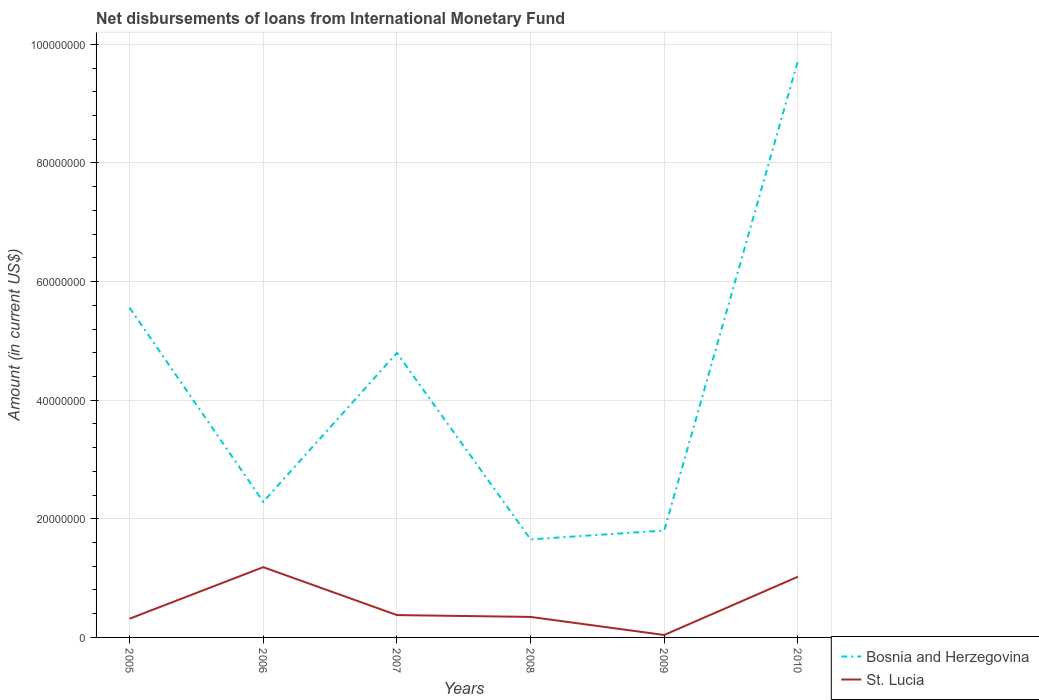How many different coloured lines are there?
Give a very brief answer. 2. Does the line corresponding to Bosnia and Herzegovina intersect with the line corresponding to St. Lucia?
Give a very brief answer. No. Is the number of lines equal to the number of legend labels?
Keep it short and to the point. Yes. Across all years, what is the maximum amount of loans disbursed in St. Lucia?
Provide a succinct answer. 4.12e+05. In which year was the amount of loans disbursed in St. Lucia maximum?
Provide a short and direct response. 2009. What is the total amount of loans disbursed in St. Lucia in the graph?
Ensure brevity in your answer.  3.04e+06. What is the difference between the highest and the second highest amount of loans disbursed in St. Lucia?
Provide a succinct answer. 1.14e+07. How many years are there in the graph?
Provide a succinct answer. 6. Are the values on the major ticks of Y-axis written in scientific E-notation?
Offer a very short reply. No. Does the graph contain grids?
Keep it short and to the point. Yes. Where does the legend appear in the graph?
Ensure brevity in your answer.  Bottom right. How many legend labels are there?
Your answer should be very brief. 2. What is the title of the graph?
Your response must be concise. Net disbursements of loans from International Monetary Fund. What is the label or title of the Y-axis?
Ensure brevity in your answer.  Amount (in current US$). What is the Amount (in current US$) of Bosnia and Herzegovina in 2005?
Your response must be concise. 5.56e+07. What is the Amount (in current US$) of St. Lucia in 2005?
Offer a very short reply. 3.16e+06. What is the Amount (in current US$) in Bosnia and Herzegovina in 2006?
Offer a very short reply. 2.29e+07. What is the Amount (in current US$) in St. Lucia in 2006?
Your answer should be very brief. 1.18e+07. What is the Amount (in current US$) in Bosnia and Herzegovina in 2007?
Your response must be concise. 4.80e+07. What is the Amount (in current US$) in St. Lucia in 2007?
Make the answer very short. 3.77e+06. What is the Amount (in current US$) of Bosnia and Herzegovina in 2008?
Give a very brief answer. 1.65e+07. What is the Amount (in current US$) in St. Lucia in 2008?
Provide a short and direct response. 3.46e+06. What is the Amount (in current US$) in Bosnia and Herzegovina in 2009?
Your answer should be very brief. 1.80e+07. What is the Amount (in current US$) of St. Lucia in 2009?
Make the answer very short. 4.12e+05. What is the Amount (in current US$) of Bosnia and Herzegovina in 2010?
Ensure brevity in your answer.  9.72e+07. What is the Amount (in current US$) in St. Lucia in 2010?
Provide a short and direct response. 1.02e+07. Across all years, what is the maximum Amount (in current US$) of Bosnia and Herzegovina?
Make the answer very short. 9.72e+07. Across all years, what is the maximum Amount (in current US$) of St. Lucia?
Your answer should be very brief. 1.18e+07. Across all years, what is the minimum Amount (in current US$) in Bosnia and Herzegovina?
Provide a succinct answer. 1.65e+07. Across all years, what is the minimum Amount (in current US$) in St. Lucia?
Your answer should be very brief. 4.12e+05. What is the total Amount (in current US$) in Bosnia and Herzegovina in the graph?
Your answer should be very brief. 2.58e+08. What is the total Amount (in current US$) of St. Lucia in the graph?
Your response must be concise. 3.29e+07. What is the difference between the Amount (in current US$) in Bosnia and Herzegovina in 2005 and that in 2006?
Offer a terse response. 3.27e+07. What is the difference between the Amount (in current US$) in St. Lucia in 2005 and that in 2006?
Keep it short and to the point. -8.69e+06. What is the difference between the Amount (in current US$) in Bosnia and Herzegovina in 2005 and that in 2007?
Provide a short and direct response. 7.63e+06. What is the difference between the Amount (in current US$) in St. Lucia in 2005 and that in 2007?
Your answer should be very brief. -6.09e+05. What is the difference between the Amount (in current US$) of Bosnia and Herzegovina in 2005 and that in 2008?
Provide a succinct answer. 3.91e+07. What is the difference between the Amount (in current US$) of St. Lucia in 2005 and that in 2008?
Provide a succinct answer. -2.97e+05. What is the difference between the Amount (in current US$) in Bosnia and Herzegovina in 2005 and that in 2009?
Your answer should be very brief. 3.76e+07. What is the difference between the Amount (in current US$) in St. Lucia in 2005 and that in 2009?
Offer a terse response. 2.75e+06. What is the difference between the Amount (in current US$) of Bosnia and Herzegovina in 2005 and that in 2010?
Provide a short and direct response. -4.16e+07. What is the difference between the Amount (in current US$) in St. Lucia in 2005 and that in 2010?
Keep it short and to the point. -7.07e+06. What is the difference between the Amount (in current US$) in Bosnia and Herzegovina in 2006 and that in 2007?
Give a very brief answer. -2.51e+07. What is the difference between the Amount (in current US$) in St. Lucia in 2006 and that in 2007?
Provide a succinct answer. 8.08e+06. What is the difference between the Amount (in current US$) of Bosnia and Herzegovina in 2006 and that in 2008?
Provide a succinct answer. 6.33e+06. What is the difference between the Amount (in current US$) in St. Lucia in 2006 and that in 2008?
Your answer should be very brief. 8.39e+06. What is the difference between the Amount (in current US$) of Bosnia and Herzegovina in 2006 and that in 2009?
Your response must be concise. 4.84e+06. What is the difference between the Amount (in current US$) of St. Lucia in 2006 and that in 2009?
Keep it short and to the point. 1.14e+07. What is the difference between the Amount (in current US$) of Bosnia and Herzegovina in 2006 and that in 2010?
Provide a succinct answer. -7.43e+07. What is the difference between the Amount (in current US$) in St. Lucia in 2006 and that in 2010?
Provide a succinct answer. 1.62e+06. What is the difference between the Amount (in current US$) of Bosnia and Herzegovina in 2007 and that in 2008?
Ensure brevity in your answer.  3.14e+07. What is the difference between the Amount (in current US$) in St. Lucia in 2007 and that in 2008?
Provide a short and direct response. 3.12e+05. What is the difference between the Amount (in current US$) in Bosnia and Herzegovina in 2007 and that in 2009?
Ensure brevity in your answer.  2.99e+07. What is the difference between the Amount (in current US$) of St. Lucia in 2007 and that in 2009?
Give a very brief answer. 3.36e+06. What is the difference between the Amount (in current US$) in Bosnia and Herzegovina in 2007 and that in 2010?
Make the answer very short. -4.92e+07. What is the difference between the Amount (in current US$) in St. Lucia in 2007 and that in 2010?
Your answer should be very brief. -6.46e+06. What is the difference between the Amount (in current US$) in Bosnia and Herzegovina in 2008 and that in 2009?
Your answer should be very brief. -1.49e+06. What is the difference between the Amount (in current US$) of St. Lucia in 2008 and that in 2009?
Make the answer very short. 3.04e+06. What is the difference between the Amount (in current US$) in Bosnia and Herzegovina in 2008 and that in 2010?
Offer a terse response. -8.07e+07. What is the difference between the Amount (in current US$) in St. Lucia in 2008 and that in 2010?
Your answer should be compact. -6.77e+06. What is the difference between the Amount (in current US$) in Bosnia and Herzegovina in 2009 and that in 2010?
Offer a terse response. -7.92e+07. What is the difference between the Amount (in current US$) in St. Lucia in 2009 and that in 2010?
Ensure brevity in your answer.  -9.82e+06. What is the difference between the Amount (in current US$) of Bosnia and Herzegovina in 2005 and the Amount (in current US$) of St. Lucia in 2006?
Provide a short and direct response. 4.37e+07. What is the difference between the Amount (in current US$) in Bosnia and Herzegovina in 2005 and the Amount (in current US$) in St. Lucia in 2007?
Keep it short and to the point. 5.18e+07. What is the difference between the Amount (in current US$) of Bosnia and Herzegovina in 2005 and the Amount (in current US$) of St. Lucia in 2008?
Your answer should be compact. 5.21e+07. What is the difference between the Amount (in current US$) of Bosnia and Herzegovina in 2005 and the Amount (in current US$) of St. Lucia in 2009?
Offer a very short reply. 5.52e+07. What is the difference between the Amount (in current US$) in Bosnia and Herzegovina in 2005 and the Amount (in current US$) in St. Lucia in 2010?
Offer a terse response. 4.54e+07. What is the difference between the Amount (in current US$) of Bosnia and Herzegovina in 2006 and the Amount (in current US$) of St. Lucia in 2007?
Make the answer very short. 1.91e+07. What is the difference between the Amount (in current US$) in Bosnia and Herzegovina in 2006 and the Amount (in current US$) in St. Lucia in 2008?
Provide a succinct answer. 1.94e+07. What is the difference between the Amount (in current US$) in Bosnia and Herzegovina in 2006 and the Amount (in current US$) in St. Lucia in 2009?
Your answer should be compact. 2.25e+07. What is the difference between the Amount (in current US$) of Bosnia and Herzegovina in 2006 and the Amount (in current US$) of St. Lucia in 2010?
Make the answer very short. 1.26e+07. What is the difference between the Amount (in current US$) of Bosnia and Herzegovina in 2007 and the Amount (in current US$) of St. Lucia in 2008?
Your answer should be very brief. 4.45e+07. What is the difference between the Amount (in current US$) in Bosnia and Herzegovina in 2007 and the Amount (in current US$) in St. Lucia in 2009?
Offer a very short reply. 4.76e+07. What is the difference between the Amount (in current US$) in Bosnia and Herzegovina in 2007 and the Amount (in current US$) in St. Lucia in 2010?
Your response must be concise. 3.77e+07. What is the difference between the Amount (in current US$) of Bosnia and Herzegovina in 2008 and the Amount (in current US$) of St. Lucia in 2009?
Your answer should be compact. 1.61e+07. What is the difference between the Amount (in current US$) in Bosnia and Herzegovina in 2008 and the Amount (in current US$) in St. Lucia in 2010?
Make the answer very short. 6.30e+06. What is the difference between the Amount (in current US$) of Bosnia and Herzegovina in 2009 and the Amount (in current US$) of St. Lucia in 2010?
Provide a short and direct response. 7.79e+06. What is the average Amount (in current US$) of Bosnia and Herzegovina per year?
Keep it short and to the point. 4.30e+07. What is the average Amount (in current US$) of St. Lucia per year?
Offer a terse response. 5.48e+06. In the year 2005, what is the difference between the Amount (in current US$) in Bosnia and Herzegovina and Amount (in current US$) in St. Lucia?
Your answer should be compact. 5.24e+07. In the year 2006, what is the difference between the Amount (in current US$) of Bosnia and Herzegovina and Amount (in current US$) of St. Lucia?
Offer a very short reply. 1.10e+07. In the year 2007, what is the difference between the Amount (in current US$) in Bosnia and Herzegovina and Amount (in current US$) in St. Lucia?
Provide a short and direct response. 4.42e+07. In the year 2008, what is the difference between the Amount (in current US$) in Bosnia and Herzegovina and Amount (in current US$) in St. Lucia?
Provide a short and direct response. 1.31e+07. In the year 2009, what is the difference between the Amount (in current US$) in Bosnia and Herzegovina and Amount (in current US$) in St. Lucia?
Your answer should be very brief. 1.76e+07. In the year 2010, what is the difference between the Amount (in current US$) in Bosnia and Herzegovina and Amount (in current US$) in St. Lucia?
Give a very brief answer. 8.70e+07. What is the ratio of the Amount (in current US$) of Bosnia and Herzegovina in 2005 to that in 2006?
Ensure brevity in your answer.  2.43. What is the ratio of the Amount (in current US$) in St. Lucia in 2005 to that in 2006?
Ensure brevity in your answer.  0.27. What is the ratio of the Amount (in current US$) of Bosnia and Herzegovina in 2005 to that in 2007?
Provide a succinct answer. 1.16. What is the ratio of the Amount (in current US$) of St. Lucia in 2005 to that in 2007?
Offer a very short reply. 0.84. What is the ratio of the Amount (in current US$) in Bosnia and Herzegovina in 2005 to that in 2008?
Your answer should be compact. 3.36. What is the ratio of the Amount (in current US$) of St. Lucia in 2005 to that in 2008?
Make the answer very short. 0.91. What is the ratio of the Amount (in current US$) in Bosnia and Herzegovina in 2005 to that in 2009?
Your response must be concise. 3.08. What is the ratio of the Amount (in current US$) of St. Lucia in 2005 to that in 2009?
Keep it short and to the point. 7.67. What is the ratio of the Amount (in current US$) in Bosnia and Herzegovina in 2005 to that in 2010?
Keep it short and to the point. 0.57. What is the ratio of the Amount (in current US$) of St. Lucia in 2005 to that in 2010?
Your answer should be very brief. 0.31. What is the ratio of the Amount (in current US$) in Bosnia and Herzegovina in 2006 to that in 2007?
Your answer should be very brief. 0.48. What is the ratio of the Amount (in current US$) of St. Lucia in 2006 to that in 2007?
Keep it short and to the point. 3.14. What is the ratio of the Amount (in current US$) in Bosnia and Herzegovina in 2006 to that in 2008?
Your response must be concise. 1.38. What is the ratio of the Amount (in current US$) in St. Lucia in 2006 to that in 2008?
Give a very brief answer. 3.43. What is the ratio of the Amount (in current US$) in Bosnia and Herzegovina in 2006 to that in 2009?
Your answer should be very brief. 1.27. What is the ratio of the Amount (in current US$) of St. Lucia in 2006 to that in 2009?
Your response must be concise. 28.75. What is the ratio of the Amount (in current US$) in Bosnia and Herzegovina in 2006 to that in 2010?
Make the answer very short. 0.24. What is the ratio of the Amount (in current US$) of St. Lucia in 2006 to that in 2010?
Ensure brevity in your answer.  1.16. What is the ratio of the Amount (in current US$) in Bosnia and Herzegovina in 2007 to that in 2008?
Offer a very short reply. 2.9. What is the ratio of the Amount (in current US$) in St. Lucia in 2007 to that in 2008?
Ensure brevity in your answer.  1.09. What is the ratio of the Amount (in current US$) of Bosnia and Herzegovina in 2007 to that in 2009?
Make the answer very short. 2.66. What is the ratio of the Amount (in current US$) in St. Lucia in 2007 to that in 2009?
Offer a very short reply. 9.15. What is the ratio of the Amount (in current US$) of Bosnia and Herzegovina in 2007 to that in 2010?
Ensure brevity in your answer.  0.49. What is the ratio of the Amount (in current US$) of St. Lucia in 2007 to that in 2010?
Make the answer very short. 0.37. What is the ratio of the Amount (in current US$) in Bosnia and Herzegovina in 2008 to that in 2009?
Offer a terse response. 0.92. What is the ratio of the Amount (in current US$) of St. Lucia in 2008 to that in 2009?
Make the answer very short. 8.39. What is the ratio of the Amount (in current US$) in Bosnia and Herzegovina in 2008 to that in 2010?
Your answer should be very brief. 0.17. What is the ratio of the Amount (in current US$) of St. Lucia in 2008 to that in 2010?
Keep it short and to the point. 0.34. What is the ratio of the Amount (in current US$) in Bosnia and Herzegovina in 2009 to that in 2010?
Give a very brief answer. 0.19. What is the ratio of the Amount (in current US$) of St. Lucia in 2009 to that in 2010?
Provide a short and direct response. 0.04. What is the difference between the highest and the second highest Amount (in current US$) of Bosnia and Herzegovina?
Provide a short and direct response. 4.16e+07. What is the difference between the highest and the second highest Amount (in current US$) of St. Lucia?
Make the answer very short. 1.62e+06. What is the difference between the highest and the lowest Amount (in current US$) of Bosnia and Herzegovina?
Ensure brevity in your answer.  8.07e+07. What is the difference between the highest and the lowest Amount (in current US$) in St. Lucia?
Offer a terse response. 1.14e+07. 